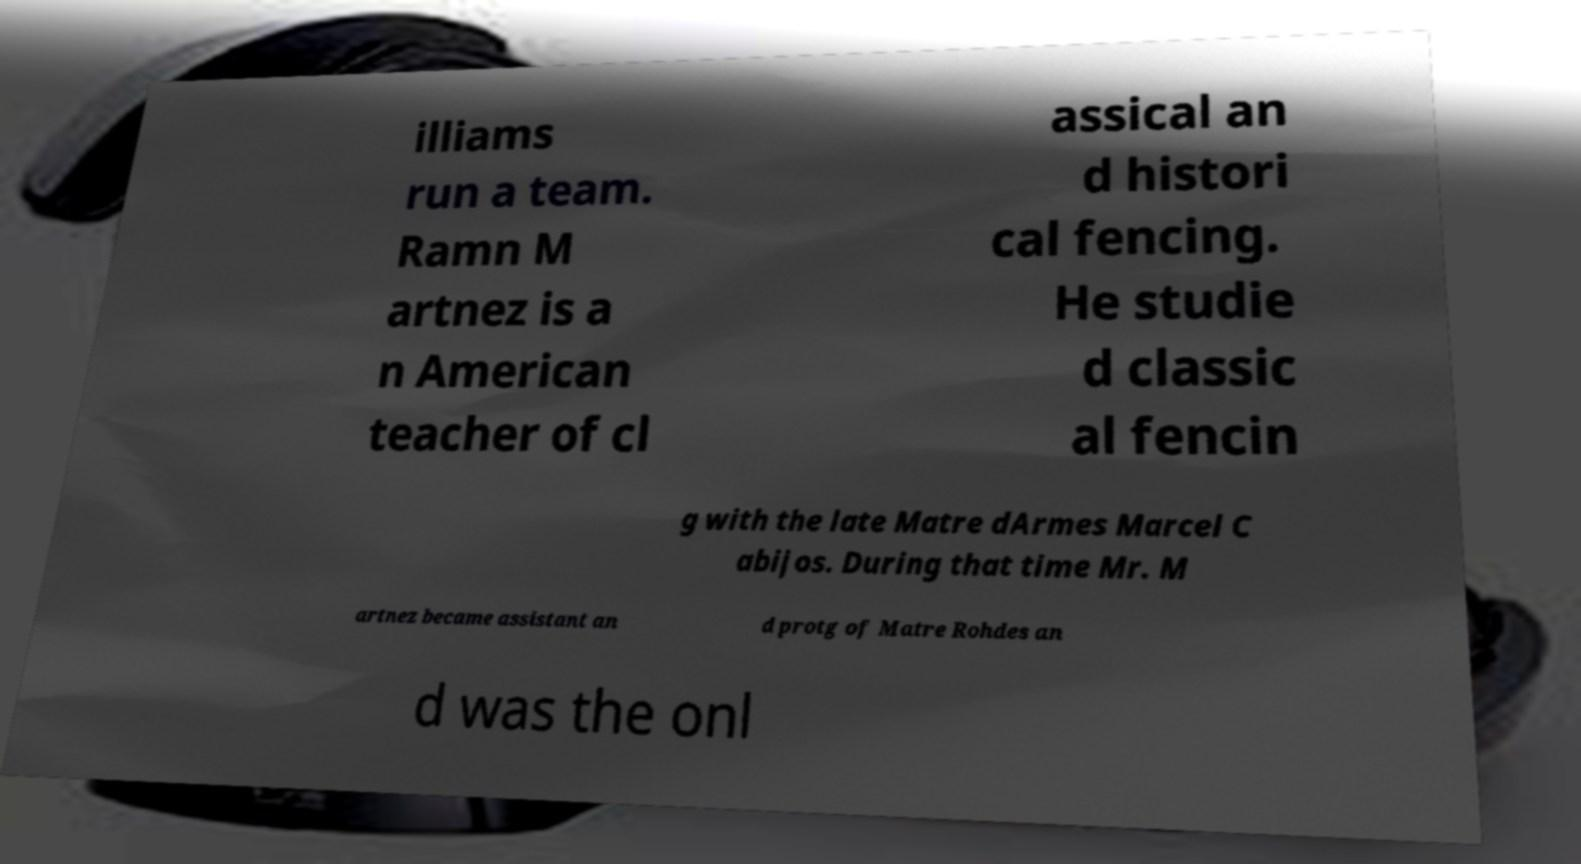There's text embedded in this image that I need extracted. Can you transcribe it verbatim? illiams run a team. Ramn M artnez is a n American teacher of cl assical an d histori cal fencing. He studie d classic al fencin g with the late Matre dArmes Marcel C abijos. During that time Mr. M artnez became assistant an d protg of Matre Rohdes an d was the onl 